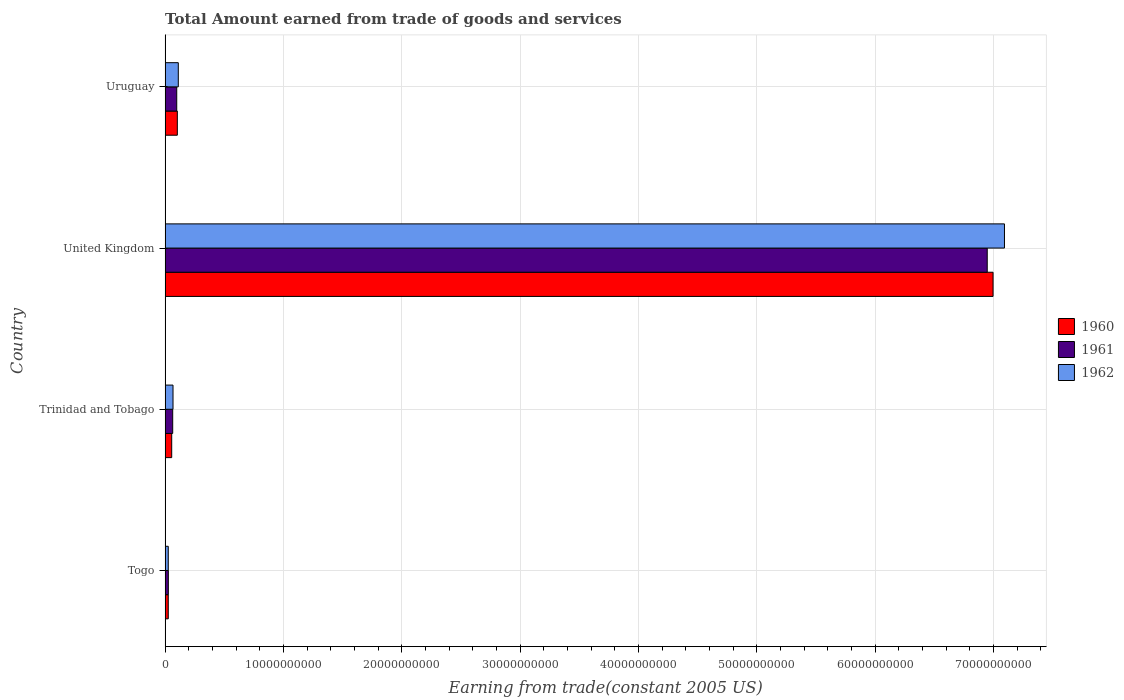Are the number of bars per tick equal to the number of legend labels?
Give a very brief answer. Yes. How many bars are there on the 3rd tick from the top?
Your answer should be compact. 3. How many bars are there on the 3rd tick from the bottom?
Offer a terse response. 3. What is the label of the 1st group of bars from the top?
Your answer should be compact. Uruguay. What is the total amount earned by trading goods and services in 1961 in Togo?
Your answer should be compact. 2.74e+08. Across all countries, what is the maximum total amount earned by trading goods and services in 1961?
Your answer should be very brief. 6.95e+1. Across all countries, what is the minimum total amount earned by trading goods and services in 1962?
Offer a very short reply. 2.68e+08. In which country was the total amount earned by trading goods and services in 1960 minimum?
Provide a short and direct response. Togo. What is the total total amount earned by trading goods and services in 1961 in the graph?
Your answer should be very brief. 7.14e+1. What is the difference between the total amount earned by trading goods and services in 1960 in Togo and that in United Kingdom?
Ensure brevity in your answer.  -6.97e+1. What is the difference between the total amount earned by trading goods and services in 1961 in United Kingdom and the total amount earned by trading goods and services in 1962 in Togo?
Give a very brief answer. 6.92e+1. What is the average total amount earned by trading goods and services in 1960 per country?
Give a very brief answer. 1.80e+1. What is the difference between the total amount earned by trading goods and services in 1960 and total amount earned by trading goods and services in 1961 in Togo?
Give a very brief answer. -5.83e+06. In how many countries, is the total amount earned by trading goods and services in 1960 greater than 30000000000 US$?
Make the answer very short. 1. What is the ratio of the total amount earned by trading goods and services in 1960 in United Kingdom to that in Uruguay?
Make the answer very short. 67.66. What is the difference between the highest and the second highest total amount earned by trading goods and services in 1960?
Keep it short and to the point. 6.89e+1. What is the difference between the highest and the lowest total amount earned by trading goods and services in 1962?
Offer a very short reply. 7.07e+1. In how many countries, is the total amount earned by trading goods and services in 1962 greater than the average total amount earned by trading goods and services in 1962 taken over all countries?
Provide a succinct answer. 1. Is the sum of the total amount earned by trading goods and services in 1961 in Togo and United Kingdom greater than the maximum total amount earned by trading goods and services in 1962 across all countries?
Ensure brevity in your answer.  No. What does the 3rd bar from the top in United Kingdom represents?
Keep it short and to the point. 1960. What does the 3rd bar from the bottom in Trinidad and Tobago represents?
Keep it short and to the point. 1962. Is it the case that in every country, the sum of the total amount earned by trading goods and services in 1961 and total amount earned by trading goods and services in 1962 is greater than the total amount earned by trading goods and services in 1960?
Your answer should be compact. Yes. Are all the bars in the graph horizontal?
Give a very brief answer. Yes. Are the values on the major ticks of X-axis written in scientific E-notation?
Provide a short and direct response. No. Does the graph contain grids?
Your response must be concise. Yes. How many legend labels are there?
Give a very brief answer. 3. What is the title of the graph?
Give a very brief answer. Total Amount earned from trade of goods and services. Does "1998" appear as one of the legend labels in the graph?
Offer a terse response. No. What is the label or title of the X-axis?
Offer a very short reply. Earning from trade(constant 2005 US). What is the Earning from trade(constant 2005 US) of 1960 in Togo?
Your answer should be compact. 2.68e+08. What is the Earning from trade(constant 2005 US) of 1961 in Togo?
Provide a short and direct response. 2.74e+08. What is the Earning from trade(constant 2005 US) of 1962 in Togo?
Your answer should be compact. 2.68e+08. What is the Earning from trade(constant 2005 US) of 1960 in Trinidad and Tobago?
Your response must be concise. 5.58e+08. What is the Earning from trade(constant 2005 US) in 1961 in Trinidad and Tobago?
Your response must be concise. 6.42e+08. What is the Earning from trade(constant 2005 US) in 1962 in Trinidad and Tobago?
Your answer should be very brief. 6.69e+08. What is the Earning from trade(constant 2005 US) in 1960 in United Kingdom?
Keep it short and to the point. 7.00e+1. What is the Earning from trade(constant 2005 US) in 1961 in United Kingdom?
Offer a terse response. 6.95e+1. What is the Earning from trade(constant 2005 US) of 1962 in United Kingdom?
Offer a very short reply. 7.09e+1. What is the Earning from trade(constant 2005 US) of 1960 in Uruguay?
Make the answer very short. 1.03e+09. What is the Earning from trade(constant 2005 US) in 1961 in Uruguay?
Provide a short and direct response. 9.84e+08. What is the Earning from trade(constant 2005 US) of 1962 in Uruguay?
Offer a terse response. 1.12e+09. Across all countries, what is the maximum Earning from trade(constant 2005 US) in 1960?
Keep it short and to the point. 7.00e+1. Across all countries, what is the maximum Earning from trade(constant 2005 US) in 1961?
Provide a short and direct response. 6.95e+1. Across all countries, what is the maximum Earning from trade(constant 2005 US) in 1962?
Keep it short and to the point. 7.09e+1. Across all countries, what is the minimum Earning from trade(constant 2005 US) of 1960?
Offer a terse response. 2.68e+08. Across all countries, what is the minimum Earning from trade(constant 2005 US) in 1961?
Ensure brevity in your answer.  2.74e+08. Across all countries, what is the minimum Earning from trade(constant 2005 US) in 1962?
Offer a terse response. 2.68e+08. What is the total Earning from trade(constant 2005 US) of 1960 in the graph?
Your answer should be compact. 7.18e+1. What is the total Earning from trade(constant 2005 US) in 1961 in the graph?
Make the answer very short. 7.14e+1. What is the total Earning from trade(constant 2005 US) in 1962 in the graph?
Provide a succinct answer. 7.30e+1. What is the difference between the Earning from trade(constant 2005 US) in 1960 in Togo and that in Trinidad and Tobago?
Give a very brief answer. -2.90e+08. What is the difference between the Earning from trade(constant 2005 US) of 1961 in Togo and that in Trinidad and Tobago?
Give a very brief answer. -3.68e+08. What is the difference between the Earning from trade(constant 2005 US) of 1962 in Togo and that in Trinidad and Tobago?
Keep it short and to the point. -4.01e+08. What is the difference between the Earning from trade(constant 2005 US) of 1960 in Togo and that in United Kingdom?
Provide a short and direct response. -6.97e+1. What is the difference between the Earning from trade(constant 2005 US) of 1961 in Togo and that in United Kingdom?
Your answer should be compact. -6.92e+1. What is the difference between the Earning from trade(constant 2005 US) of 1962 in Togo and that in United Kingdom?
Your answer should be very brief. -7.07e+1. What is the difference between the Earning from trade(constant 2005 US) of 1960 in Togo and that in Uruguay?
Provide a short and direct response. -7.66e+08. What is the difference between the Earning from trade(constant 2005 US) in 1961 in Togo and that in Uruguay?
Provide a succinct answer. -7.10e+08. What is the difference between the Earning from trade(constant 2005 US) in 1962 in Togo and that in Uruguay?
Ensure brevity in your answer.  -8.48e+08. What is the difference between the Earning from trade(constant 2005 US) in 1960 in Trinidad and Tobago and that in United Kingdom?
Offer a terse response. -6.94e+1. What is the difference between the Earning from trade(constant 2005 US) of 1961 in Trinidad and Tobago and that in United Kingdom?
Make the answer very short. -6.88e+1. What is the difference between the Earning from trade(constant 2005 US) in 1962 in Trinidad and Tobago and that in United Kingdom?
Keep it short and to the point. -7.03e+1. What is the difference between the Earning from trade(constant 2005 US) of 1960 in Trinidad and Tobago and that in Uruguay?
Your answer should be compact. -4.76e+08. What is the difference between the Earning from trade(constant 2005 US) of 1961 in Trinidad and Tobago and that in Uruguay?
Keep it short and to the point. -3.41e+08. What is the difference between the Earning from trade(constant 2005 US) of 1962 in Trinidad and Tobago and that in Uruguay?
Provide a short and direct response. -4.46e+08. What is the difference between the Earning from trade(constant 2005 US) in 1960 in United Kingdom and that in Uruguay?
Keep it short and to the point. 6.89e+1. What is the difference between the Earning from trade(constant 2005 US) of 1961 in United Kingdom and that in Uruguay?
Offer a very short reply. 6.85e+1. What is the difference between the Earning from trade(constant 2005 US) in 1962 in United Kingdom and that in Uruguay?
Offer a terse response. 6.98e+1. What is the difference between the Earning from trade(constant 2005 US) in 1960 in Togo and the Earning from trade(constant 2005 US) in 1961 in Trinidad and Tobago?
Your response must be concise. -3.74e+08. What is the difference between the Earning from trade(constant 2005 US) in 1960 in Togo and the Earning from trade(constant 2005 US) in 1962 in Trinidad and Tobago?
Ensure brevity in your answer.  -4.01e+08. What is the difference between the Earning from trade(constant 2005 US) in 1961 in Togo and the Earning from trade(constant 2005 US) in 1962 in Trinidad and Tobago?
Your response must be concise. -3.95e+08. What is the difference between the Earning from trade(constant 2005 US) of 1960 in Togo and the Earning from trade(constant 2005 US) of 1961 in United Kingdom?
Provide a short and direct response. -6.92e+1. What is the difference between the Earning from trade(constant 2005 US) in 1960 in Togo and the Earning from trade(constant 2005 US) in 1962 in United Kingdom?
Your answer should be very brief. -7.07e+1. What is the difference between the Earning from trade(constant 2005 US) of 1961 in Togo and the Earning from trade(constant 2005 US) of 1962 in United Kingdom?
Ensure brevity in your answer.  -7.07e+1. What is the difference between the Earning from trade(constant 2005 US) of 1960 in Togo and the Earning from trade(constant 2005 US) of 1961 in Uruguay?
Make the answer very short. -7.16e+08. What is the difference between the Earning from trade(constant 2005 US) in 1960 in Togo and the Earning from trade(constant 2005 US) in 1962 in Uruguay?
Provide a succinct answer. -8.48e+08. What is the difference between the Earning from trade(constant 2005 US) in 1961 in Togo and the Earning from trade(constant 2005 US) in 1962 in Uruguay?
Provide a succinct answer. -8.42e+08. What is the difference between the Earning from trade(constant 2005 US) in 1960 in Trinidad and Tobago and the Earning from trade(constant 2005 US) in 1961 in United Kingdom?
Offer a very short reply. -6.89e+1. What is the difference between the Earning from trade(constant 2005 US) of 1960 in Trinidad and Tobago and the Earning from trade(constant 2005 US) of 1962 in United Kingdom?
Offer a very short reply. -7.04e+1. What is the difference between the Earning from trade(constant 2005 US) of 1961 in Trinidad and Tobago and the Earning from trade(constant 2005 US) of 1962 in United Kingdom?
Give a very brief answer. -7.03e+1. What is the difference between the Earning from trade(constant 2005 US) of 1960 in Trinidad and Tobago and the Earning from trade(constant 2005 US) of 1961 in Uruguay?
Offer a very short reply. -4.25e+08. What is the difference between the Earning from trade(constant 2005 US) of 1960 in Trinidad and Tobago and the Earning from trade(constant 2005 US) of 1962 in Uruguay?
Keep it short and to the point. -5.57e+08. What is the difference between the Earning from trade(constant 2005 US) in 1961 in Trinidad and Tobago and the Earning from trade(constant 2005 US) in 1962 in Uruguay?
Provide a short and direct response. -4.73e+08. What is the difference between the Earning from trade(constant 2005 US) of 1960 in United Kingdom and the Earning from trade(constant 2005 US) of 1961 in Uruguay?
Provide a short and direct response. 6.90e+1. What is the difference between the Earning from trade(constant 2005 US) in 1960 in United Kingdom and the Earning from trade(constant 2005 US) in 1962 in Uruguay?
Give a very brief answer. 6.88e+1. What is the difference between the Earning from trade(constant 2005 US) in 1961 in United Kingdom and the Earning from trade(constant 2005 US) in 1962 in Uruguay?
Ensure brevity in your answer.  6.84e+1. What is the average Earning from trade(constant 2005 US) in 1960 per country?
Give a very brief answer. 1.80e+1. What is the average Earning from trade(constant 2005 US) of 1961 per country?
Offer a terse response. 1.78e+1. What is the average Earning from trade(constant 2005 US) of 1962 per country?
Make the answer very short. 1.82e+1. What is the difference between the Earning from trade(constant 2005 US) of 1960 and Earning from trade(constant 2005 US) of 1961 in Togo?
Your answer should be compact. -5.83e+06. What is the difference between the Earning from trade(constant 2005 US) in 1960 and Earning from trade(constant 2005 US) in 1962 in Togo?
Your response must be concise. 0. What is the difference between the Earning from trade(constant 2005 US) of 1961 and Earning from trade(constant 2005 US) of 1962 in Togo?
Your answer should be very brief. 5.83e+06. What is the difference between the Earning from trade(constant 2005 US) of 1960 and Earning from trade(constant 2005 US) of 1961 in Trinidad and Tobago?
Ensure brevity in your answer.  -8.36e+07. What is the difference between the Earning from trade(constant 2005 US) in 1960 and Earning from trade(constant 2005 US) in 1962 in Trinidad and Tobago?
Give a very brief answer. -1.11e+08. What is the difference between the Earning from trade(constant 2005 US) of 1961 and Earning from trade(constant 2005 US) of 1962 in Trinidad and Tobago?
Give a very brief answer. -2.69e+07. What is the difference between the Earning from trade(constant 2005 US) of 1960 and Earning from trade(constant 2005 US) of 1961 in United Kingdom?
Offer a very short reply. 4.92e+08. What is the difference between the Earning from trade(constant 2005 US) of 1960 and Earning from trade(constant 2005 US) of 1962 in United Kingdom?
Your response must be concise. -9.63e+08. What is the difference between the Earning from trade(constant 2005 US) in 1961 and Earning from trade(constant 2005 US) in 1962 in United Kingdom?
Your answer should be very brief. -1.46e+09. What is the difference between the Earning from trade(constant 2005 US) of 1960 and Earning from trade(constant 2005 US) of 1961 in Uruguay?
Your response must be concise. 5.05e+07. What is the difference between the Earning from trade(constant 2005 US) of 1960 and Earning from trade(constant 2005 US) of 1962 in Uruguay?
Provide a succinct answer. -8.14e+07. What is the difference between the Earning from trade(constant 2005 US) in 1961 and Earning from trade(constant 2005 US) in 1962 in Uruguay?
Provide a succinct answer. -1.32e+08. What is the ratio of the Earning from trade(constant 2005 US) of 1960 in Togo to that in Trinidad and Tobago?
Your answer should be very brief. 0.48. What is the ratio of the Earning from trade(constant 2005 US) of 1961 in Togo to that in Trinidad and Tobago?
Ensure brevity in your answer.  0.43. What is the ratio of the Earning from trade(constant 2005 US) of 1962 in Togo to that in Trinidad and Tobago?
Your answer should be compact. 0.4. What is the ratio of the Earning from trade(constant 2005 US) of 1960 in Togo to that in United Kingdom?
Offer a terse response. 0. What is the ratio of the Earning from trade(constant 2005 US) of 1961 in Togo to that in United Kingdom?
Make the answer very short. 0. What is the ratio of the Earning from trade(constant 2005 US) in 1962 in Togo to that in United Kingdom?
Provide a short and direct response. 0. What is the ratio of the Earning from trade(constant 2005 US) of 1960 in Togo to that in Uruguay?
Make the answer very short. 0.26. What is the ratio of the Earning from trade(constant 2005 US) of 1961 in Togo to that in Uruguay?
Provide a short and direct response. 0.28. What is the ratio of the Earning from trade(constant 2005 US) of 1962 in Togo to that in Uruguay?
Your answer should be very brief. 0.24. What is the ratio of the Earning from trade(constant 2005 US) of 1960 in Trinidad and Tobago to that in United Kingdom?
Offer a very short reply. 0.01. What is the ratio of the Earning from trade(constant 2005 US) in 1961 in Trinidad and Tobago to that in United Kingdom?
Provide a short and direct response. 0.01. What is the ratio of the Earning from trade(constant 2005 US) in 1962 in Trinidad and Tobago to that in United Kingdom?
Make the answer very short. 0.01. What is the ratio of the Earning from trade(constant 2005 US) of 1960 in Trinidad and Tobago to that in Uruguay?
Make the answer very short. 0.54. What is the ratio of the Earning from trade(constant 2005 US) of 1961 in Trinidad and Tobago to that in Uruguay?
Make the answer very short. 0.65. What is the ratio of the Earning from trade(constant 2005 US) of 1962 in Trinidad and Tobago to that in Uruguay?
Give a very brief answer. 0.6. What is the ratio of the Earning from trade(constant 2005 US) in 1960 in United Kingdom to that in Uruguay?
Your answer should be very brief. 67.66. What is the ratio of the Earning from trade(constant 2005 US) of 1961 in United Kingdom to that in Uruguay?
Offer a terse response. 70.63. What is the ratio of the Earning from trade(constant 2005 US) in 1962 in United Kingdom to that in Uruguay?
Your answer should be very brief. 63.58. What is the difference between the highest and the second highest Earning from trade(constant 2005 US) of 1960?
Provide a succinct answer. 6.89e+1. What is the difference between the highest and the second highest Earning from trade(constant 2005 US) in 1961?
Make the answer very short. 6.85e+1. What is the difference between the highest and the second highest Earning from trade(constant 2005 US) in 1962?
Provide a succinct answer. 6.98e+1. What is the difference between the highest and the lowest Earning from trade(constant 2005 US) of 1960?
Give a very brief answer. 6.97e+1. What is the difference between the highest and the lowest Earning from trade(constant 2005 US) in 1961?
Your response must be concise. 6.92e+1. What is the difference between the highest and the lowest Earning from trade(constant 2005 US) in 1962?
Your response must be concise. 7.07e+1. 